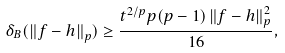<formula> <loc_0><loc_0><loc_500><loc_500>\delta _ { B } ( \left \| f - h \right \| _ { p } ) \geq \frac { t ^ { 2 / p } p ( p - 1 ) \left \| f - h \right \| _ { p } ^ { 2 } } { 1 6 } ,</formula> 